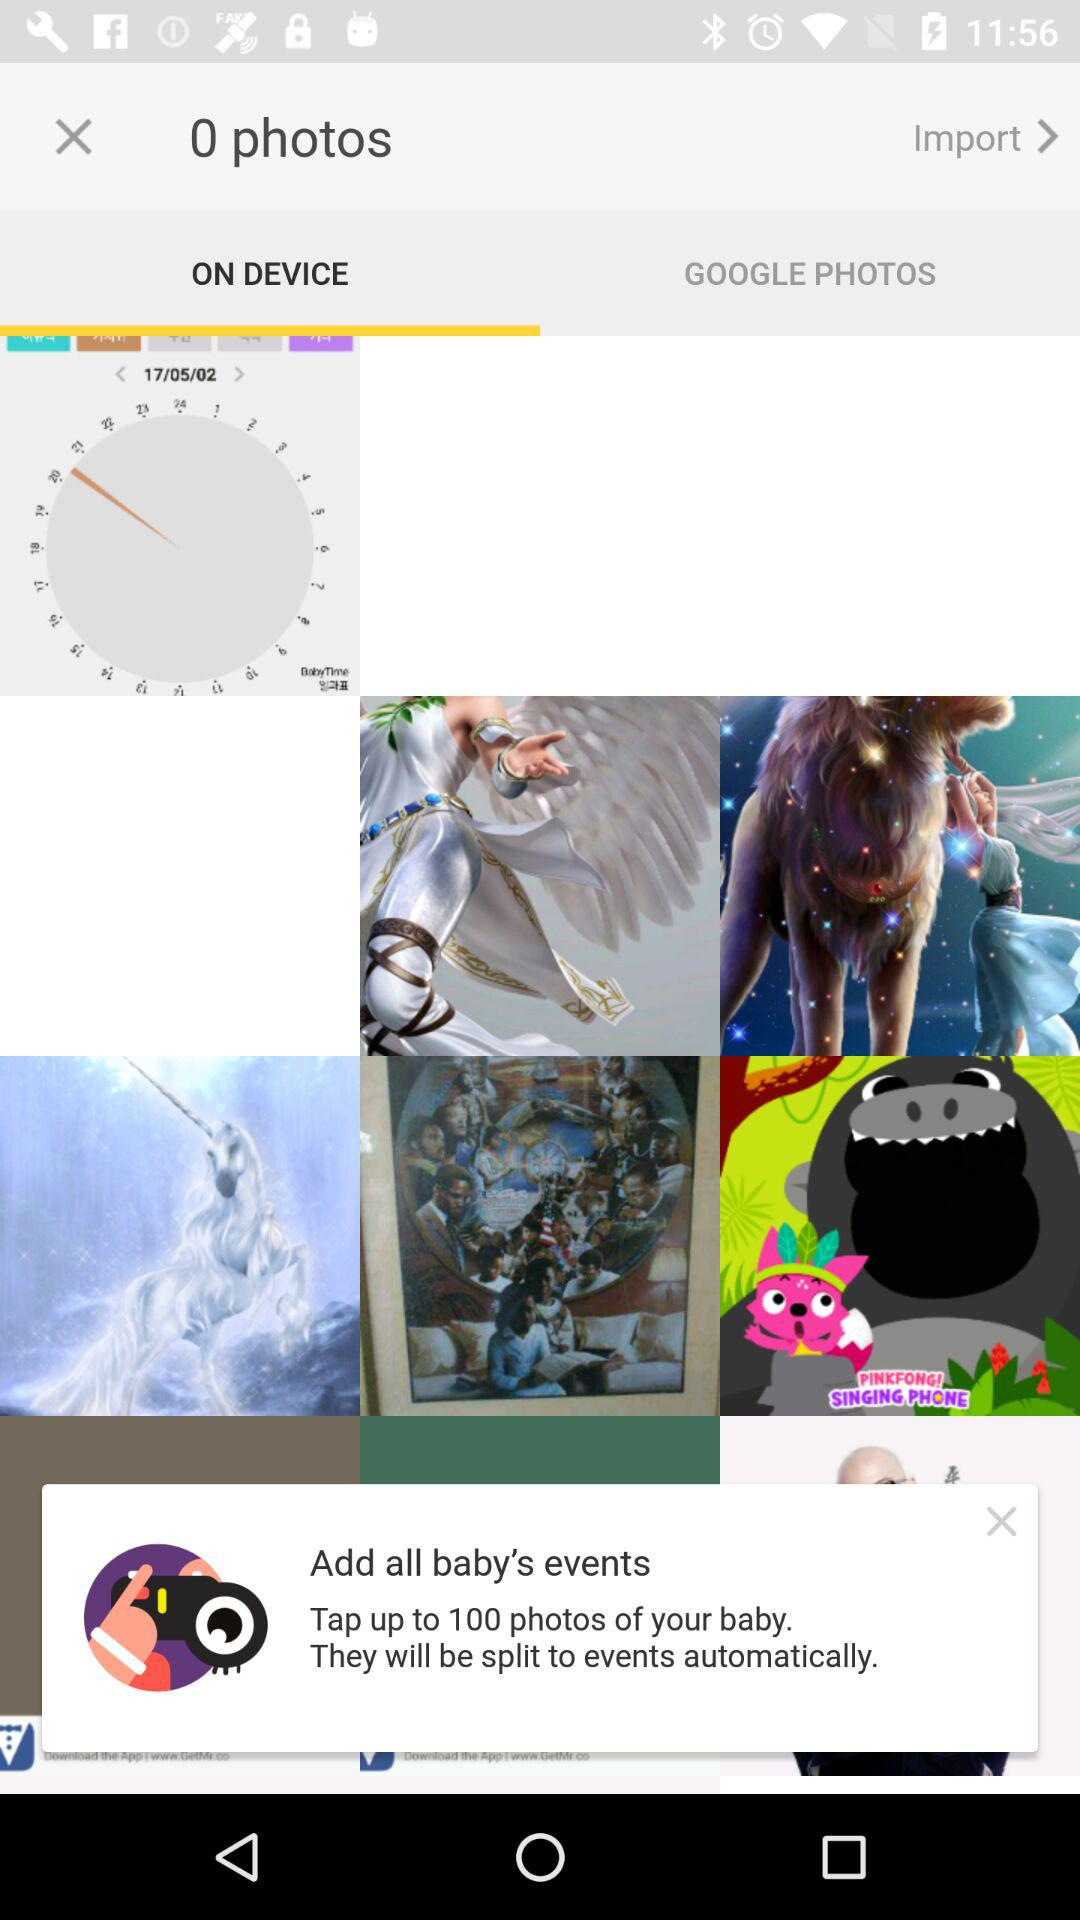Which tab is selected? The selected tab is "On Device". 